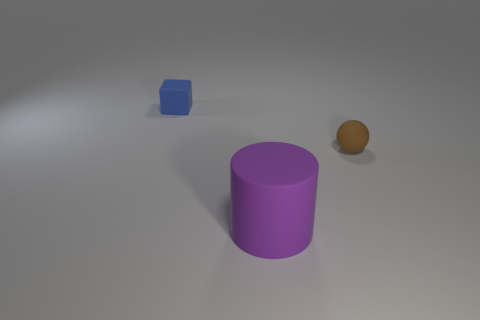Add 3 large purple rubber cylinders. How many objects exist? 6 Subtract all spheres. How many objects are left? 2 Subtract 1 brown spheres. How many objects are left? 2 Subtract all metallic blocks. Subtract all cubes. How many objects are left? 2 Add 3 cubes. How many cubes are left? 4 Add 3 brown metallic balls. How many brown metallic balls exist? 3 